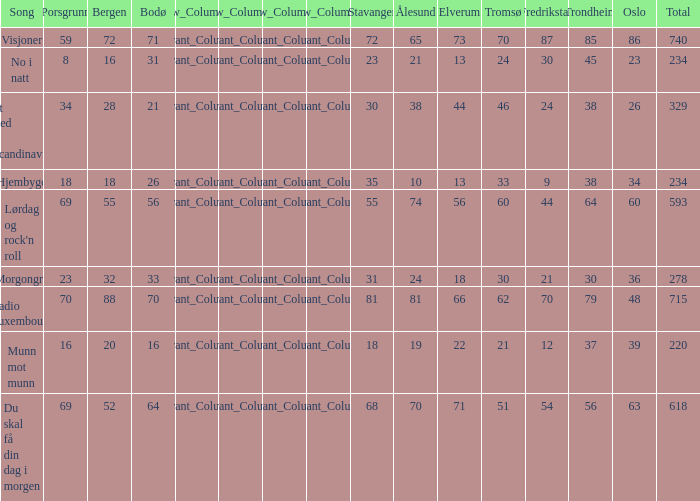What was the total for radio luxembourg? 715.0. 